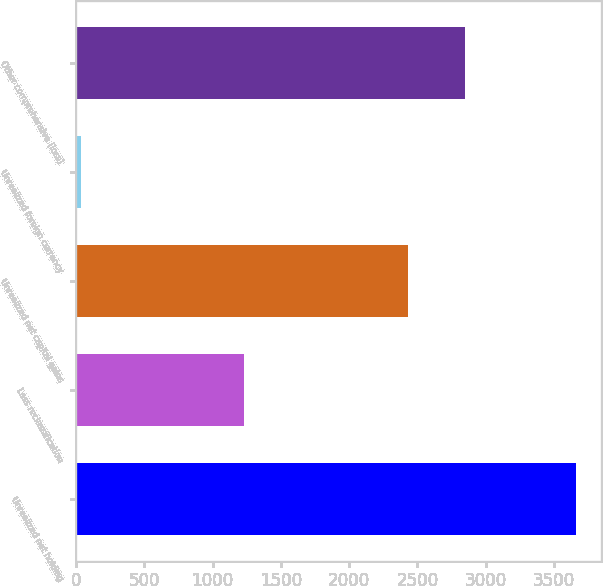Convert chart to OTSL. <chart><loc_0><loc_0><loc_500><loc_500><bar_chart><fcel>Unrealized net holding<fcel>Less reclassification<fcel>Unrealized net capital gains<fcel>Unrealized foreign currency<fcel>Other comprehensive (loss)<nl><fcel>3660<fcel>1228<fcel>2432<fcel>40<fcel>2851<nl></chart> 